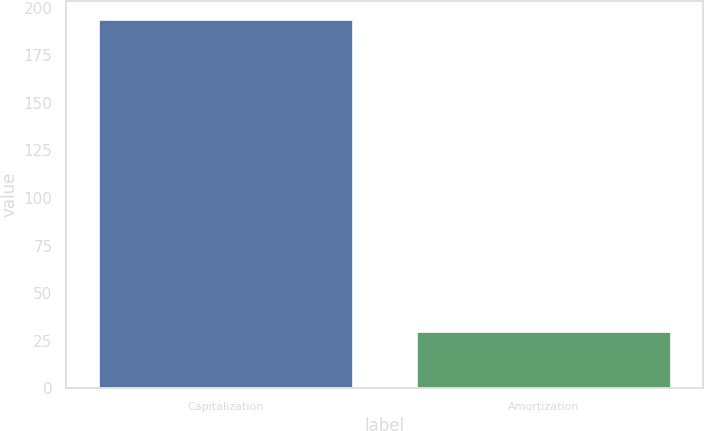<chart> <loc_0><loc_0><loc_500><loc_500><bar_chart><fcel>Capitalization<fcel>Amortization<nl><fcel>194<fcel>30<nl></chart> 